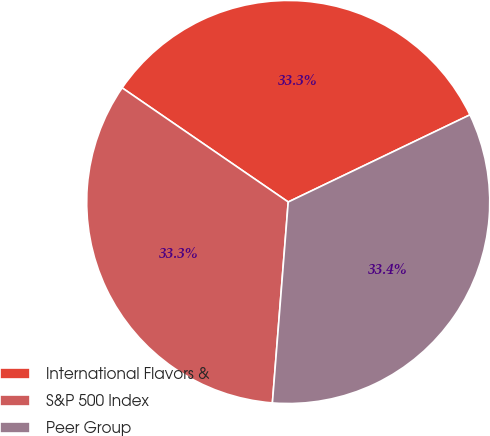<chart> <loc_0><loc_0><loc_500><loc_500><pie_chart><fcel>International Flavors &<fcel>S&P 500 Index<fcel>Peer Group<nl><fcel>33.3%<fcel>33.33%<fcel>33.37%<nl></chart> 